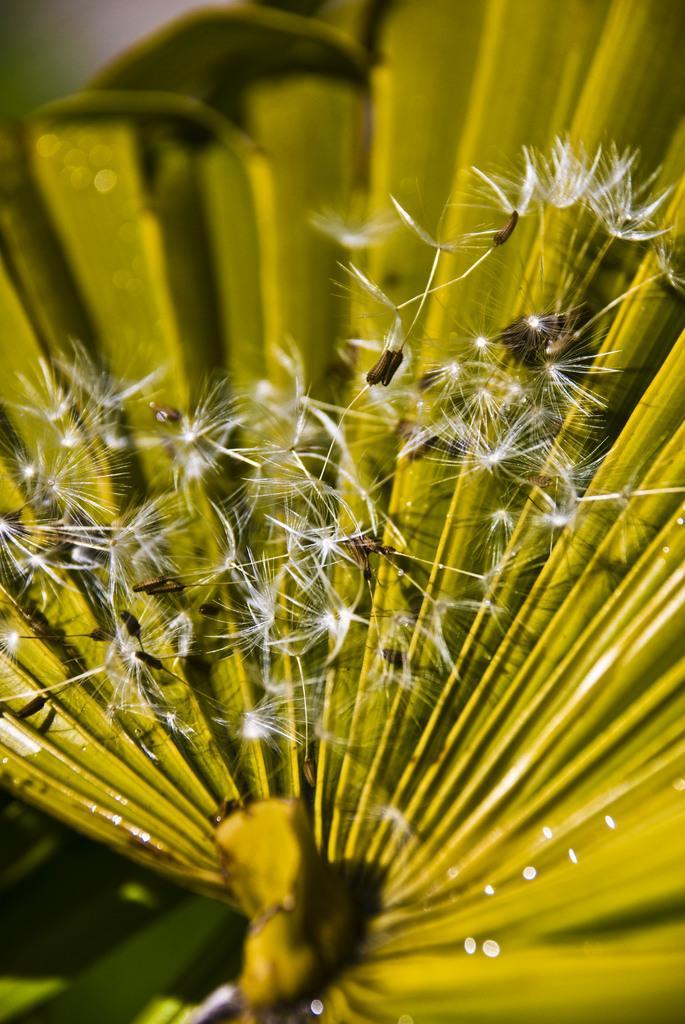In one or two sentences, can you explain what this image depicts? In this picture I can see there are few dandelions and there is a green leaf in the backdrop, the backdrop is blurred. 